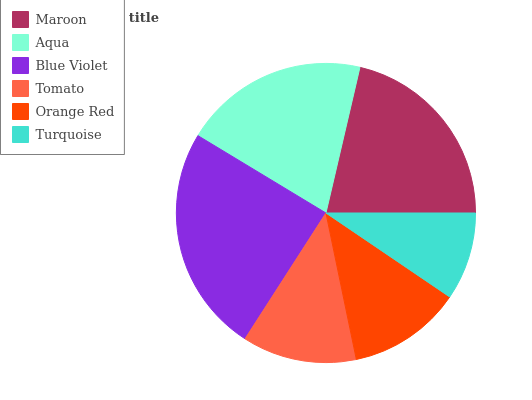Is Turquoise the minimum?
Answer yes or no. Yes. Is Blue Violet the maximum?
Answer yes or no. Yes. Is Aqua the minimum?
Answer yes or no. No. Is Aqua the maximum?
Answer yes or no. No. Is Maroon greater than Aqua?
Answer yes or no. Yes. Is Aqua less than Maroon?
Answer yes or no. Yes. Is Aqua greater than Maroon?
Answer yes or no. No. Is Maroon less than Aqua?
Answer yes or no. No. Is Aqua the high median?
Answer yes or no. Yes. Is Tomato the low median?
Answer yes or no. Yes. Is Blue Violet the high median?
Answer yes or no. No. Is Turquoise the low median?
Answer yes or no. No. 